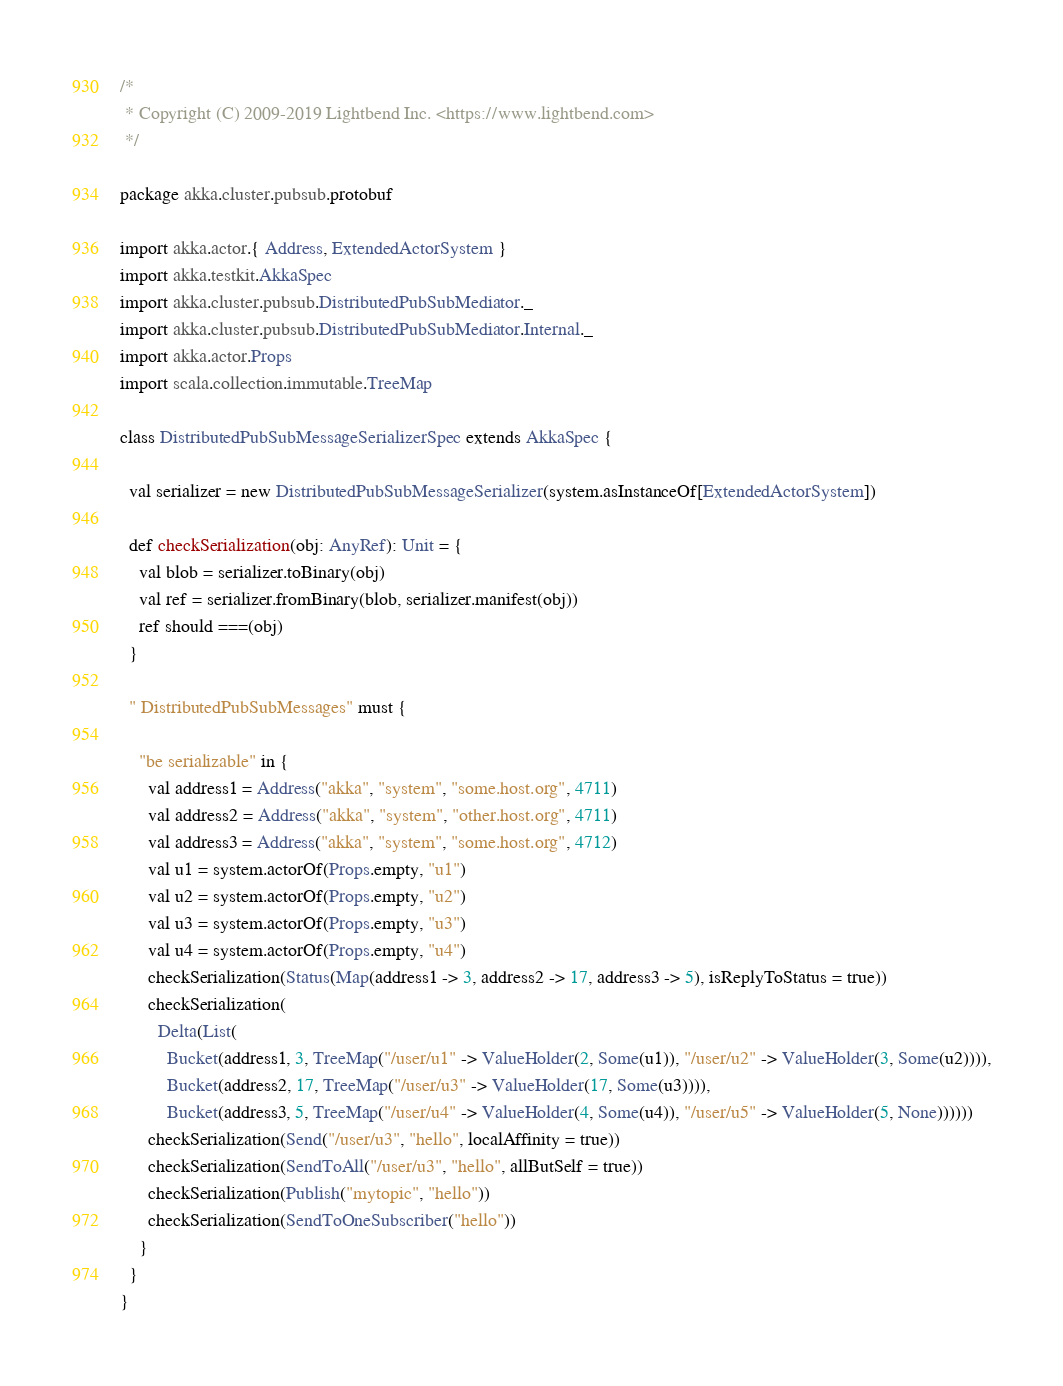Convert code to text. <code><loc_0><loc_0><loc_500><loc_500><_Scala_>/*
 * Copyright (C) 2009-2019 Lightbend Inc. <https://www.lightbend.com>
 */

package akka.cluster.pubsub.protobuf

import akka.actor.{ Address, ExtendedActorSystem }
import akka.testkit.AkkaSpec
import akka.cluster.pubsub.DistributedPubSubMediator._
import akka.cluster.pubsub.DistributedPubSubMediator.Internal._
import akka.actor.Props
import scala.collection.immutable.TreeMap

class DistributedPubSubMessageSerializerSpec extends AkkaSpec {

  val serializer = new DistributedPubSubMessageSerializer(system.asInstanceOf[ExtendedActorSystem])

  def checkSerialization(obj: AnyRef): Unit = {
    val blob = serializer.toBinary(obj)
    val ref = serializer.fromBinary(blob, serializer.manifest(obj))
    ref should ===(obj)
  }

  " DistributedPubSubMessages" must {

    "be serializable" in {
      val address1 = Address("akka", "system", "some.host.org", 4711)
      val address2 = Address("akka", "system", "other.host.org", 4711)
      val address3 = Address("akka", "system", "some.host.org", 4712)
      val u1 = system.actorOf(Props.empty, "u1")
      val u2 = system.actorOf(Props.empty, "u2")
      val u3 = system.actorOf(Props.empty, "u3")
      val u4 = system.actorOf(Props.empty, "u4")
      checkSerialization(Status(Map(address1 -> 3, address2 -> 17, address3 -> 5), isReplyToStatus = true))
      checkSerialization(
        Delta(List(
          Bucket(address1, 3, TreeMap("/user/u1" -> ValueHolder(2, Some(u1)), "/user/u2" -> ValueHolder(3, Some(u2)))),
          Bucket(address2, 17, TreeMap("/user/u3" -> ValueHolder(17, Some(u3)))),
          Bucket(address3, 5, TreeMap("/user/u4" -> ValueHolder(4, Some(u4)), "/user/u5" -> ValueHolder(5, None))))))
      checkSerialization(Send("/user/u3", "hello", localAffinity = true))
      checkSerialization(SendToAll("/user/u3", "hello", allButSelf = true))
      checkSerialization(Publish("mytopic", "hello"))
      checkSerialization(SendToOneSubscriber("hello"))
    }
  }
}
</code> 